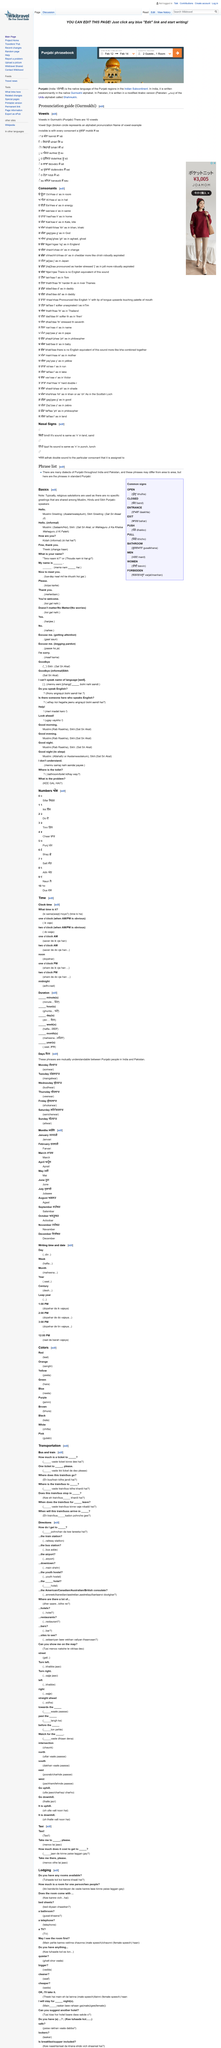Outline some significant characteristics in this image. There are many dialects of Punjabi, and no, there is not just one dialect. The Muslim greeting for "Hello" is "Asalamwalaykum". The phrases in question come from the Punjabi language. The Bindi sound is the same as the 'n' sound in words such as 'land' and 'sand'. Religious salutations are typically used in greetings. 